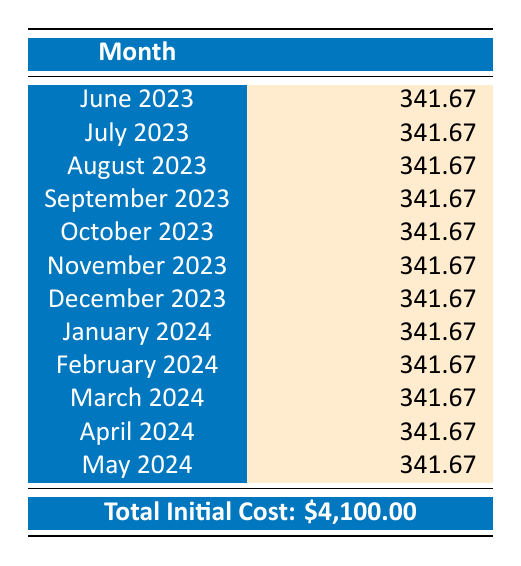What is the total initial cost of the coastal cleanup event? The total initial cost is stated in the table and clearly labeled as $4,100.00.
Answer: 4100.00 How much is the amortized cost for July 2023? The table shows the amortized cost for July 2023, which is listed as $341.67.
Answer: 341.67 Is the amortized cost the same for all months listed? By reviewing the table, all months from June 2023 to May 2024 have the same amortized cost of $341.67.
Answer: Yes What will be the total amortized cost from June 2023 to November 2023? To find the total amortized cost for six months, we calculate: $341.67 * 6 = $2,050.02.
Answer: 2050.02 What is the average monthly amortized cost for the event? The average monthly amortized cost can be found directly from the provided monthly cost, which is $341.67. Since all are the same, the average remains $341.67.
Answer: 341.67 How much will the organization spend on amortized costs from January 2024 to March 2024? We calculate the amortized cost for three months: $341.67 * 3 = $1,025.01.
Answer: 1025.01 Will the total amortized costs exceed the initial costs after one year? The total amortized costs over one year would equal the initial costs, as they amortize the total amount evenly over 12 months. Therefore, it will not exceed it.
Answer: No How much does the organization budget for the last month of the amortization schedule? The last month listed is May 2024, with an amortized cost of $341.67 as indicated in the table.
Answer: 341.67 What is the total amortized cost from December 2023 to May 2024? We calculate the total for these six months: $341.67 * 6 = $2,050.02.
Answer: 2050.02 